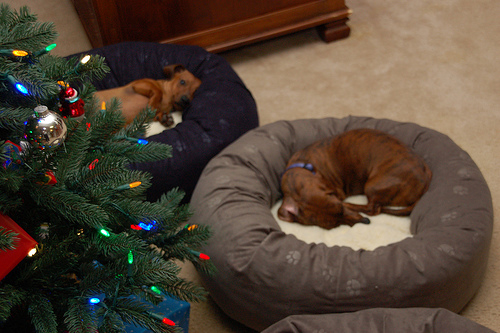<image>
Is the dog in the basket? No. The dog is not contained within the basket. These objects have a different spatial relationship. Is the dog next to the floor? No. The dog is not positioned next to the floor. They are located in different areas of the scene. 